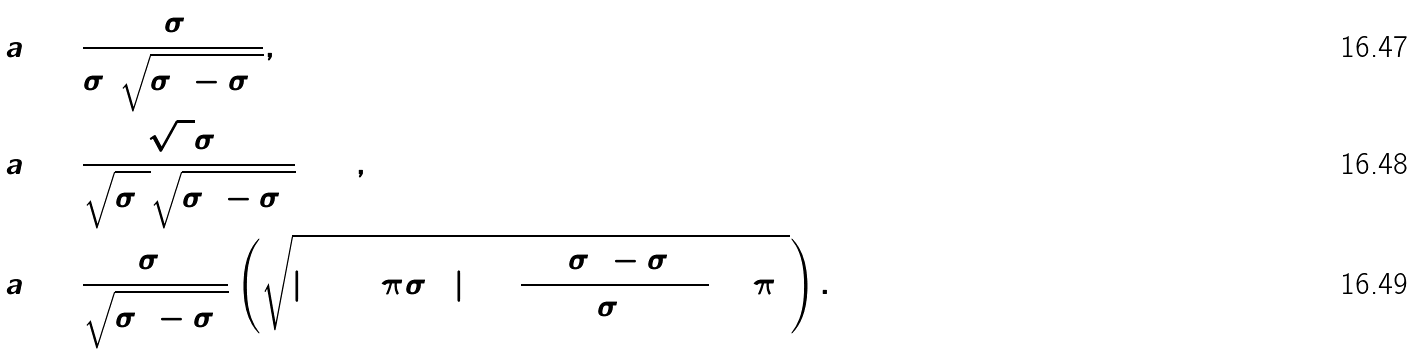Convert formula to latex. <formula><loc_0><loc_0><loc_500><loc_500>a _ { 1 } & = \frac { 3 \sigma _ { 1 } ^ { 2 } } { \sigma _ { 2 } ^ { 2 } \sqrt { \sigma _ { 2 } ^ { 2 } - \sigma _ { 1 } ^ { 2 } } } , \\ a _ { 2 } & = \frac { \sqrt { 2 } \sigma _ { 1 } ^ { 2 } } { \sqrt { \sigma _ { 2 } ^ { 2 } } \sqrt { \sigma _ { 2 } ^ { 2 } - \sigma _ { 1 } ^ { 2 } } } + 2 , \\ a _ { 3 } & = \frac { \sigma _ { 1 } ^ { 2 } } { \sqrt { \sigma _ { 2 } ^ { 2 } - \sigma _ { 1 } ^ { 2 } } } \left ( \sqrt { | \log ( 2 \pi \sigma ^ { 2 } _ { 2 } ) | ^ { 2 } + \frac { 2 4 ( \sigma _ { 2 } ^ { 2 } - \sigma _ { 1 } ^ { 2 } ) ^ { 2 } } { \sigma ^ { 4 } _ { 2 } } + \pi ^ { 2 } } \right ) .</formula> 